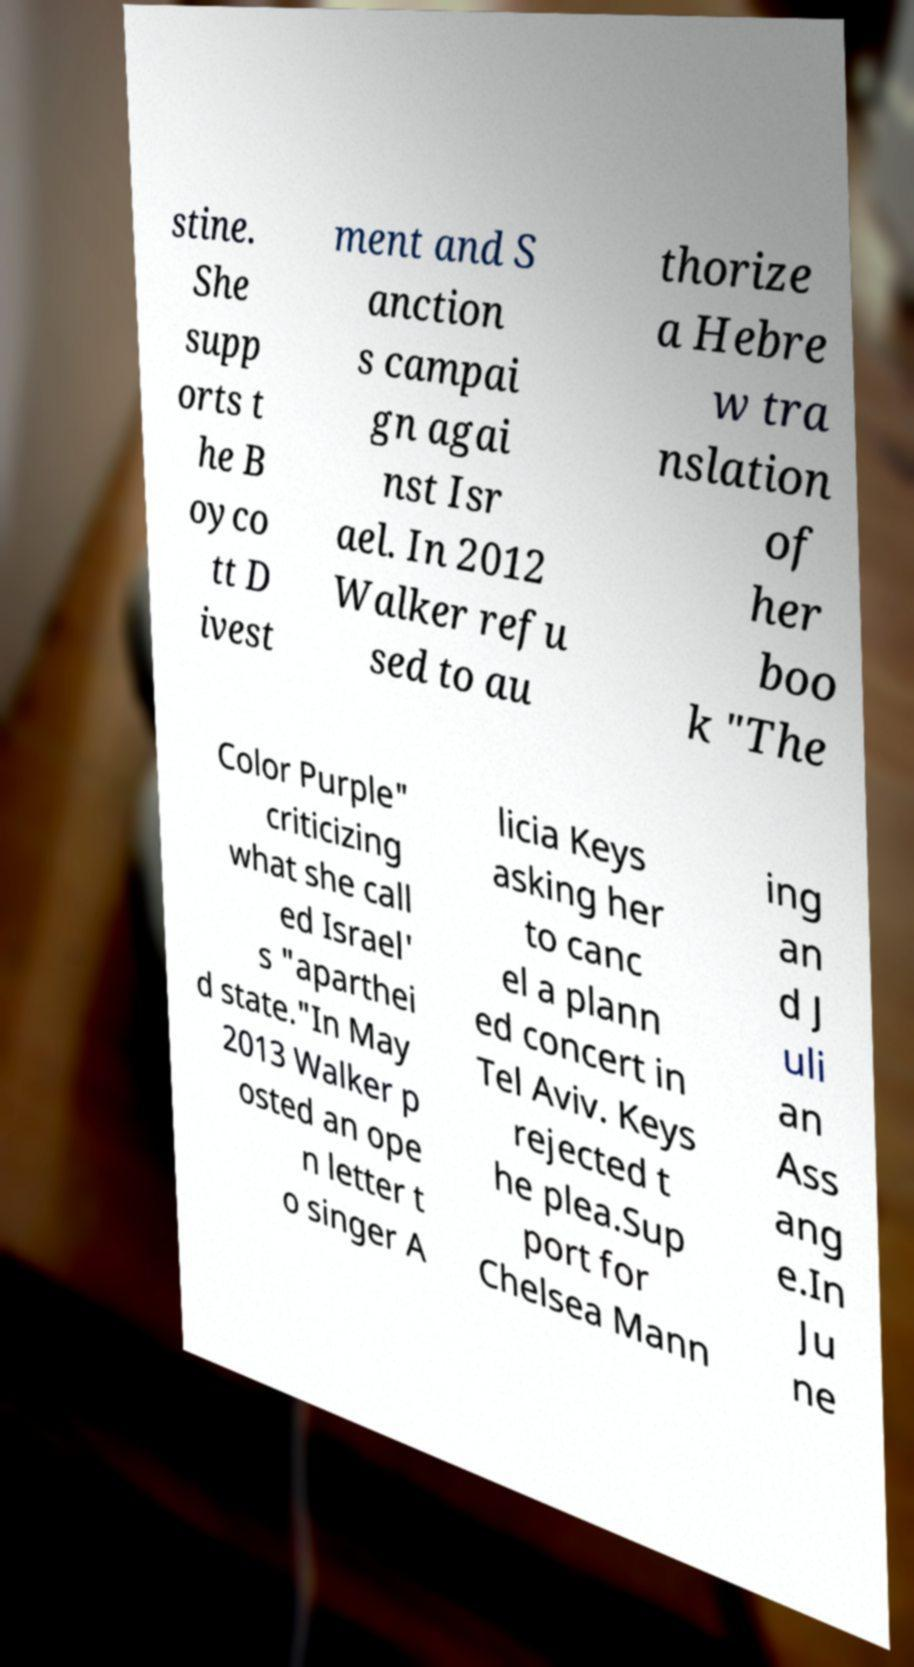Can you accurately transcribe the text from the provided image for me? stine. She supp orts t he B oyco tt D ivest ment and S anction s campai gn agai nst Isr ael. In 2012 Walker refu sed to au thorize a Hebre w tra nslation of her boo k "The Color Purple" criticizing what she call ed Israel' s "aparthei d state."In May 2013 Walker p osted an ope n letter t o singer A licia Keys asking her to canc el a plann ed concert in Tel Aviv. Keys rejected t he plea.Sup port for Chelsea Mann ing an d J uli an Ass ang e.In Ju ne 